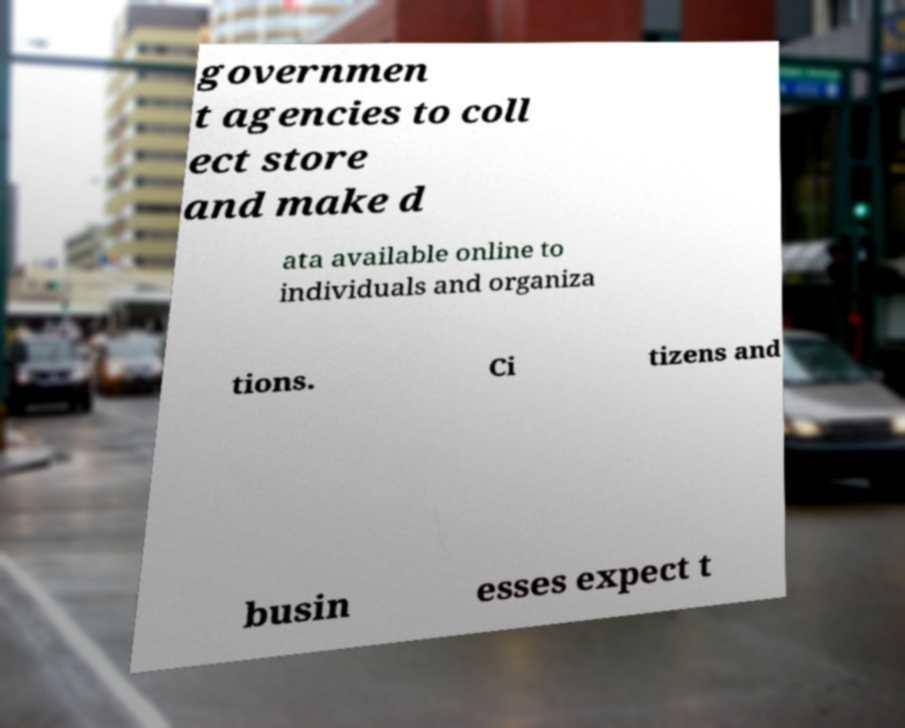Please read and relay the text visible in this image. What does it say? governmen t agencies to coll ect store and make d ata available online to individuals and organiza tions. Ci tizens and busin esses expect t 